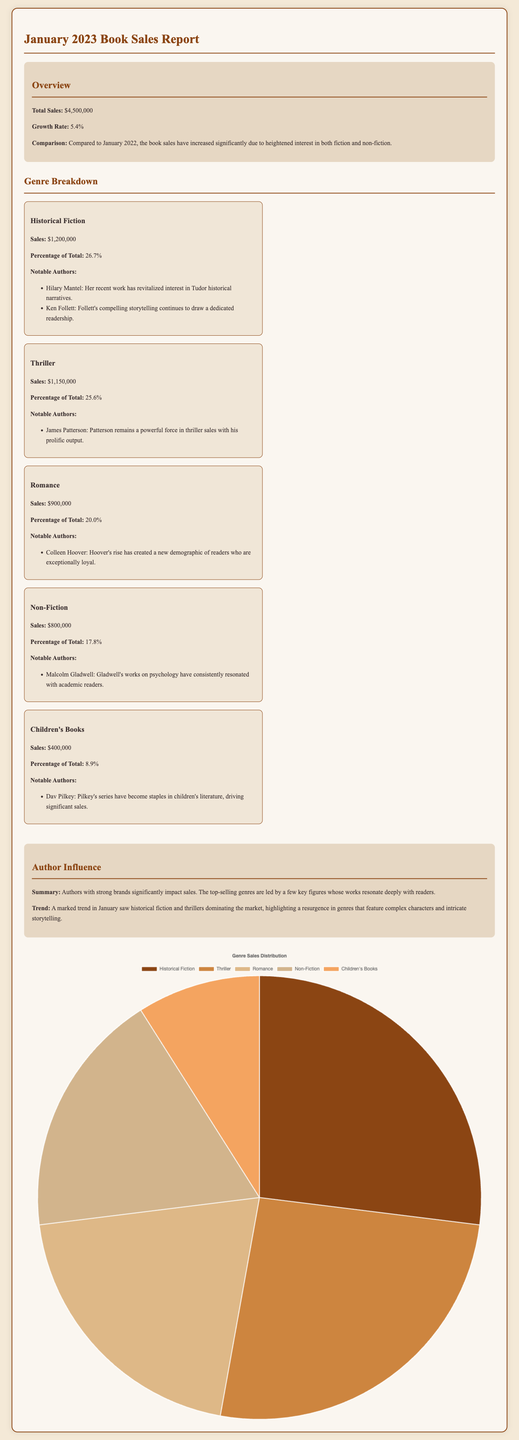What was the total sales for January 2023? The total sales are presented in the overview section of the document.
Answer: $4,500,000 Which genre had the highest sales in January 2023? The genre breakdown provides sales figures for each genre, and Historical Fiction has the highest sales.
Answer: Historical Fiction What percentage of total sales did Non-Fiction constitute? The genre breakdown includes the percentage of total sales for Non-Fiction, which is indicated clearly.
Answer: 17.8% Who are the notable authors for Romance? The document lists notable authors under each genre, specifically under Romance.
Answer: Colleen Hoover What is the growth rate compared to January 2022? The growth rate is mentioned in the overview section, comparing January 2023 to the previous year.
Answer: 5.4% Which authors are noted for their influence in Historical Fiction? The notable authors for each genre are listed, specifically mentioning those influential in Historical Fiction.
Answer: Hilary Mantel, Ken Follett Which genre had the lowest sales reported? The document lists sales for each genre, and Children's Books reflects the lowest sales figure.
Answer: Children's Books What trend is highlighted regarding genres in January 2023? The author influence section discusses market trends, specifically which genres were dominant during this period.
Answer: Historical fiction and thrillers What is the total sales percentage for Romance and Non-Fiction combined? The document provides sales percentages for each genre; their combined total needs simple addition.
Answer: 37.8% 